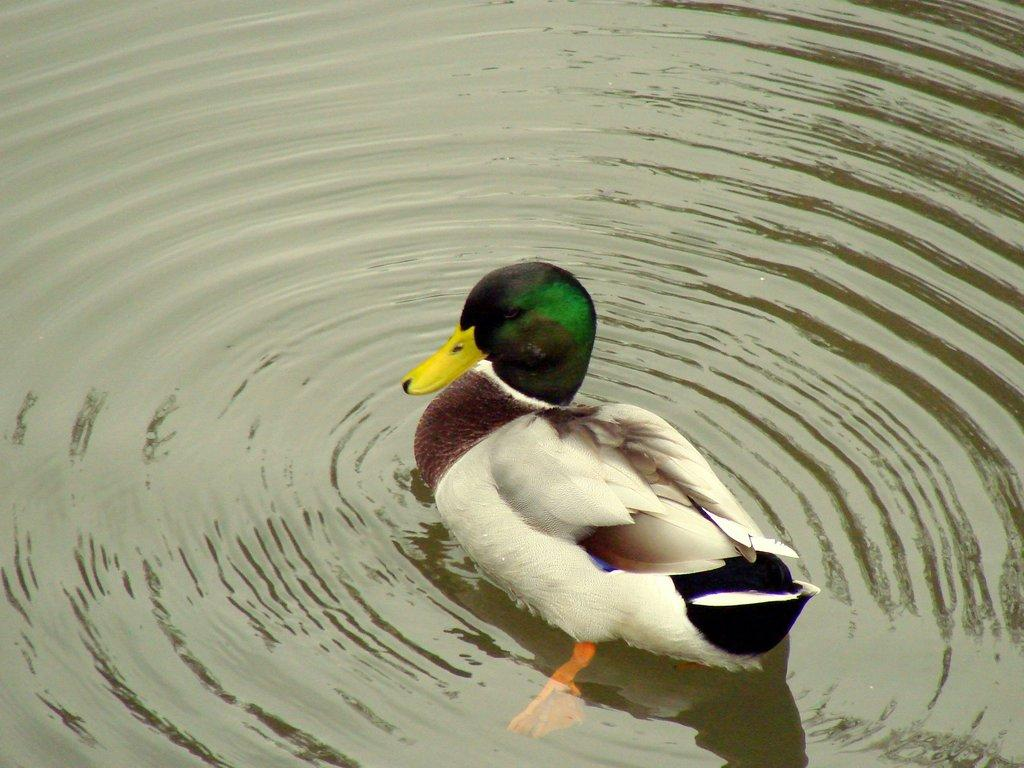What animal is present in the image? There is a duck in the image. What colors can be seen on the duck? The duck has multiple colors: white, brown, black, and green. Where is the duck located in the image? The duck is in the water. What type of metal is the duck made of in the image? The duck is not made of metal; it is a living animal. 